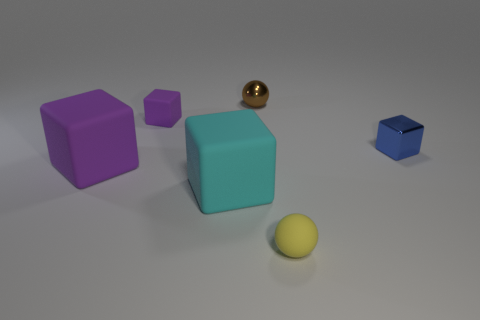Which object seems to be closest to the light source? The shiny metal ball appears to be closest to the light source, as indicated by its bright highlight and the prominence of its shadow. 